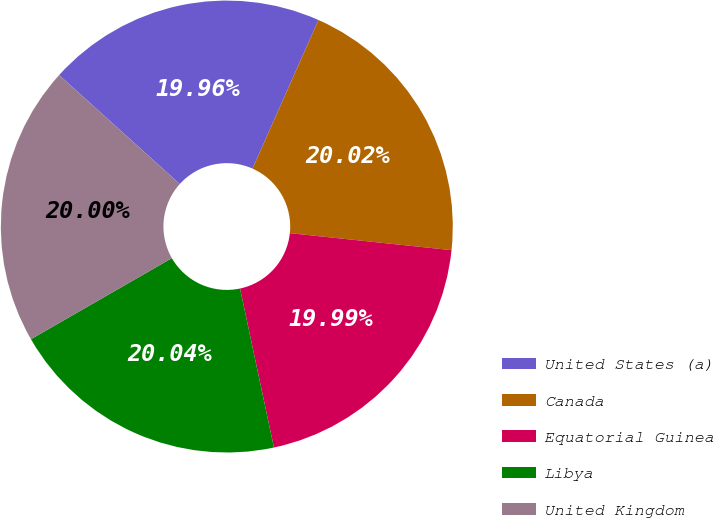Convert chart to OTSL. <chart><loc_0><loc_0><loc_500><loc_500><pie_chart><fcel>United States (a)<fcel>Canada<fcel>Equatorial Guinea<fcel>Libya<fcel>United Kingdom<nl><fcel>19.96%<fcel>20.02%<fcel>19.99%<fcel>20.04%<fcel>20.0%<nl></chart> 